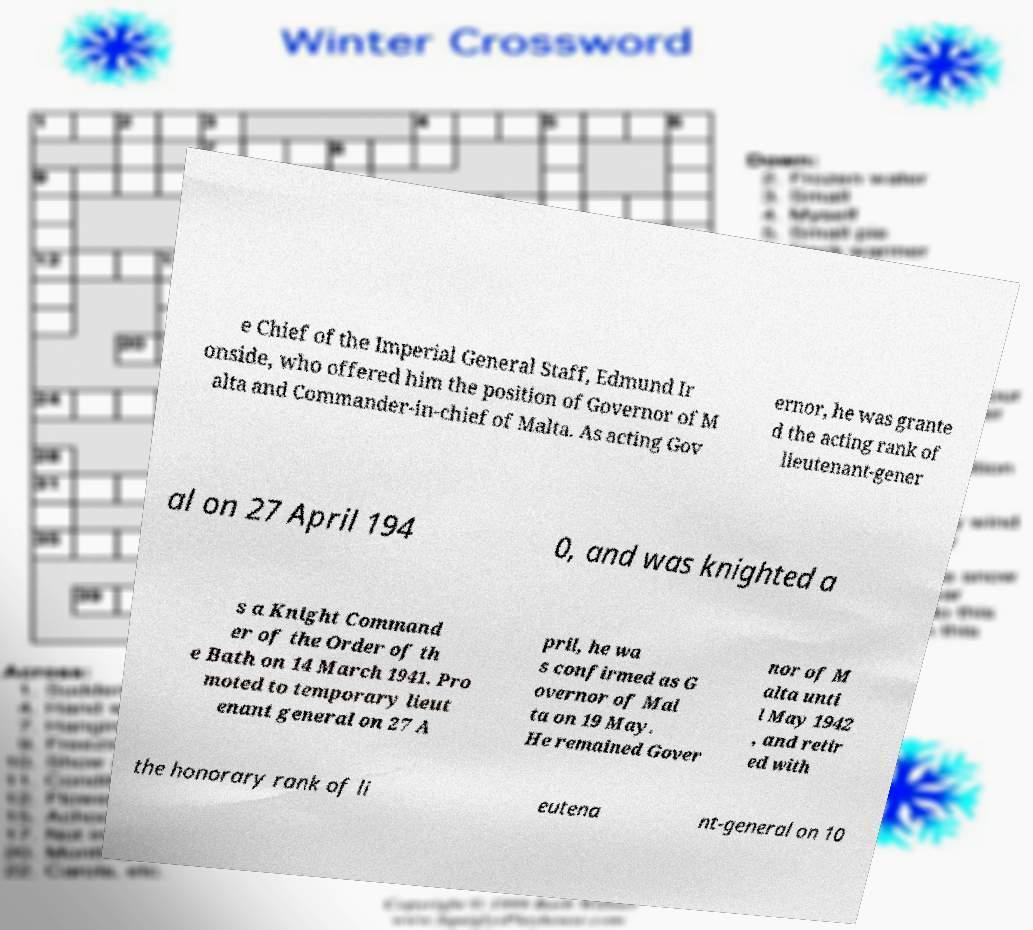Please read and relay the text visible in this image. What does it say? e Chief of the Imperial General Staff, Edmund Ir onside, who offered him the position of Governor of M alta and Commander-in-chief of Malta. As acting Gov ernor, he was grante d the acting rank of lieutenant-gener al on 27 April 194 0, and was knighted a s a Knight Command er of the Order of th e Bath on 14 March 1941. Pro moted to temporary lieut enant general on 27 A pril, he wa s confirmed as G overnor of Mal ta on 19 May. He remained Gover nor of M alta unti l May 1942 , and retir ed with the honorary rank of li eutena nt-general on 10 